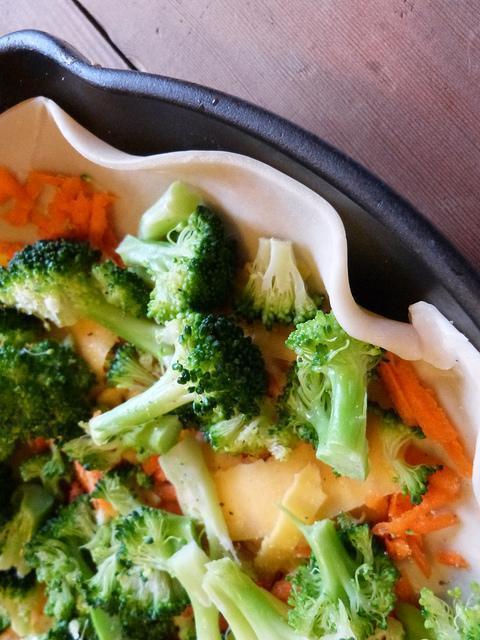How many carrots are in the photo?
Give a very brief answer. 2. How many bowls can you see?
Give a very brief answer. 2. How many broccolis are in the picture?
Give a very brief answer. 11. 